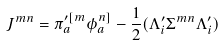Convert formula to latex. <formula><loc_0><loc_0><loc_500><loc_500>J ^ { m n } = \pi ^ { \prime [ m } _ { a } \phi ^ { n ] } _ { a } - \frac { 1 } { 2 } ( \Lambda ^ { \prime } _ { i } \Sigma ^ { m n } \Lambda ^ { \prime } _ { i } )</formula> 